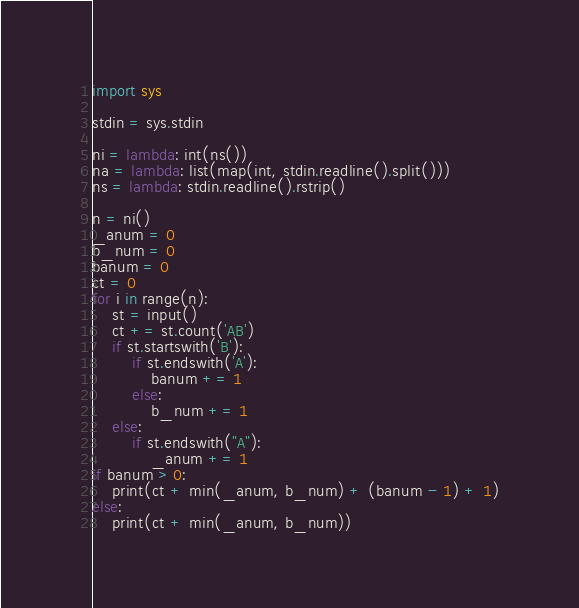<code> <loc_0><loc_0><loc_500><loc_500><_Python_>import sys

stdin = sys.stdin

ni = lambda: int(ns())
na = lambda: list(map(int, stdin.readline().split()))
ns = lambda: stdin.readline().rstrip()

n = ni()
_anum = 0
b_num = 0
banum = 0
ct = 0
for i in range(n):
    st = input()
    ct += st.count('AB')
    if st.startswith('B'):
        if st.endswith('A'):
            banum += 1
        else:
            b_num += 1
    else:
        if st.endswith("A"):
            _anum += 1
if banum > 0:
    print(ct + min(_anum, b_num) + (banum - 1) + 1)
else:
    print(ct + min(_anum, b_num))</code> 